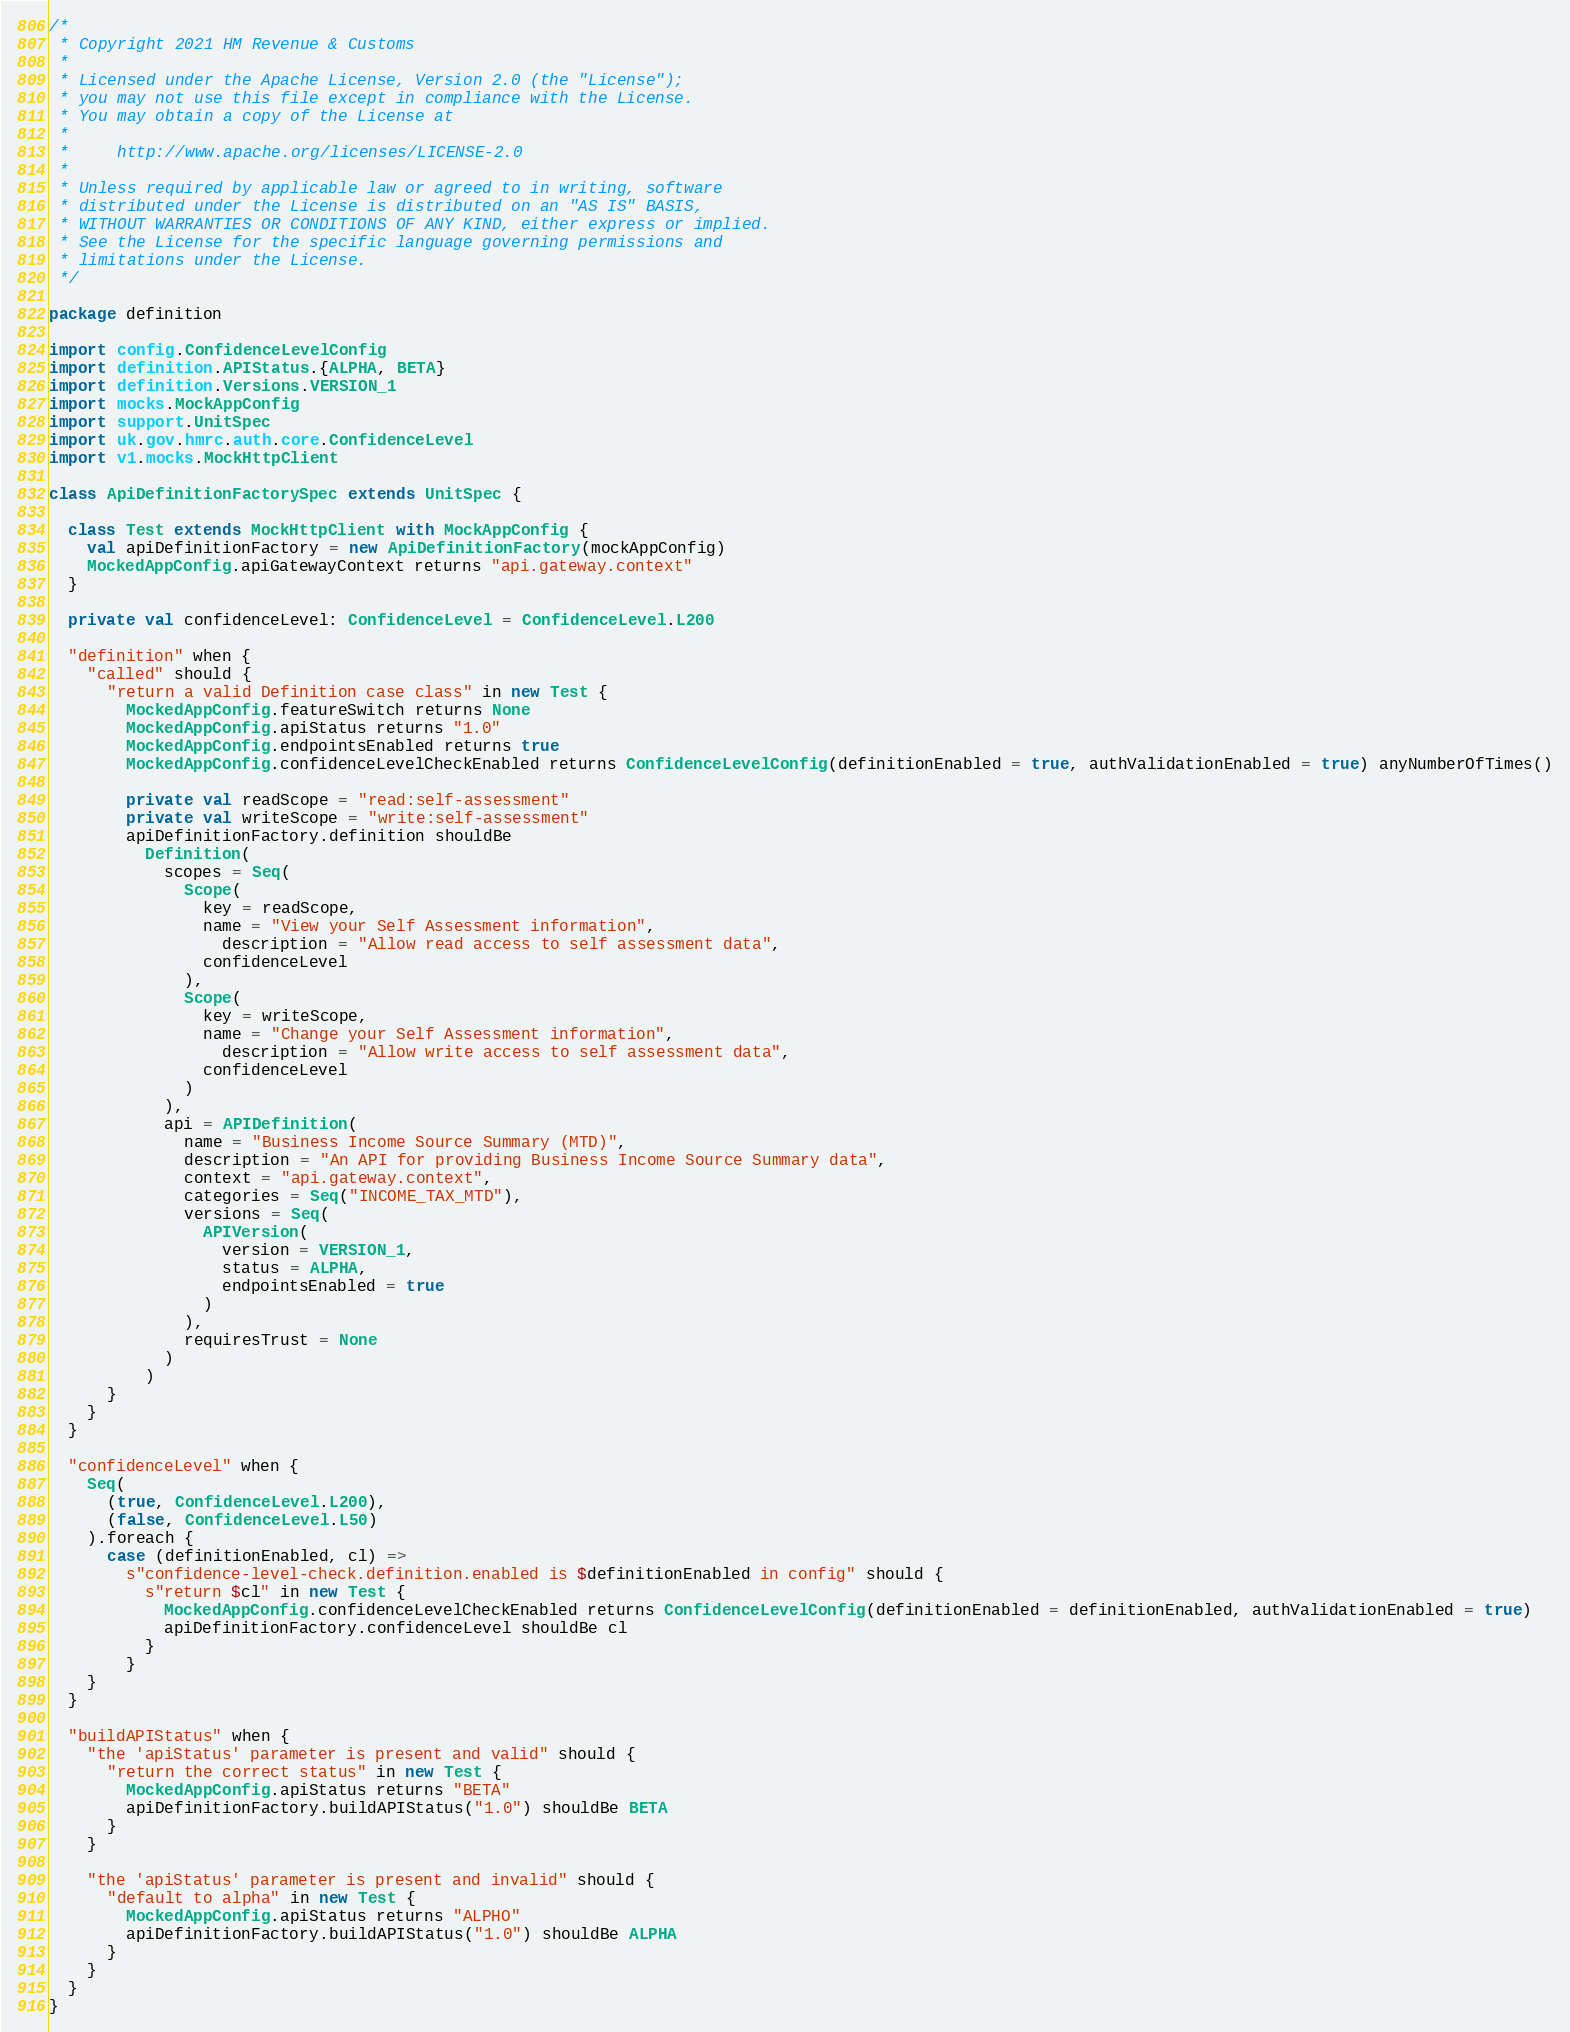Convert code to text. <code><loc_0><loc_0><loc_500><loc_500><_Scala_>/*
 * Copyright 2021 HM Revenue & Customs
 *
 * Licensed under the Apache License, Version 2.0 (the "License");
 * you may not use this file except in compliance with the License.
 * You may obtain a copy of the License at
 *
 *     http://www.apache.org/licenses/LICENSE-2.0
 *
 * Unless required by applicable law or agreed to in writing, software
 * distributed under the License is distributed on an "AS IS" BASIS,
 * WITHOUT WARRANTIES OR CONDITIONS OF ANY KIND, either express or implied.
 * See the License for the specific language governing permissions and
 * limitations under the License.
 */

package definition

import config.ConfidenceLevelConfig
import definition.APIStatus.{ALPHA, BETA}
import definition.Versions.VERSION_1
import mocks.MockAppConfig
import support.UnitSpec
import uk.gov.hmrc.auth.core.ConfidenceLevel
import v1.mocks.MockHttpClient

class ApiDefinitionFactorySpec extends UnitSpec {

  class Test extends MockHttpClient with MockAppConfig {
    val apiDefinitionFactory = new ApiDefinitionFactory(mockAppConfig)
    MockedAppConfig.apiGatewayContext returns "api.gateway.context"
  }

  private val confidenceLevel: ConfidenceLevel = ConfidenceLevel.L200

  "definition" when {
    "called" should {
      "return a valid Definition case class" in new Test {
        MockedAppConfig.featureSwitch returns None
        MockedAppConfig.apiStatus returns "1.0"
        MockedAppConfig.endpointsEnabled returns true
        MockedAppConfig.confidenceLevelCheckEnabled returns ConfidenceLevelConfig(definitionEnabled = true, authValidationEnabled = true) anyNumberOfTimes()

        private val readScope = "read:self-assessment"
        private val writeScope = "write:self-assessment"
        apiDefinitionFactory.definition shouldBe
          Definition(
            scopes = Seq(
              Scope(
                key = readScope,
                name = "View your Self Assessment information",
                  description = "Allow read access to self assessment data",
                confidenceLevel
              ),
              Scope(
                key = writeScope,
                name = "Change your Self Assessment information",
                  description = "Allow write access to self assessment data",
                confidenceLevel
              )
            ),
            api = APIDefinition(
              name = "Business Income Source Summary (MTD)",
              description = "An API for providing Business Income Source Summary data",
              context = "api.gateway.context",
              categories = Seq("INCOME_TAX_MTD"),
              versions = Seq(
                APIVersion(
                  version = VERSION_1,
                  status = ALPHA,
                  endpointsEnabled = true
                )
              ),
              requiresTrust = None
            )
          )
      }
    }
  }

  "confidenceLevel" when {
    Seq(
      (true, ConfidenceLevel.L200),
      (false, ConfidenceLevel.L50)
    ).foreach {
      case (definitionEnabled, cl) =>
        s"confidence-level-check.definition.enabled is $definitionEnabled in config" should {
          s"return $cl" in new Test {
            MockedAppConfig.confidenceLevelCheckEnabled returns ConfidenceLevelConfig(definitionEnabled = definitionEnabled, authValidationEnabled = true)
            apiDefinitionFactory.confidenceLevel shouldBe cl
          }
        }
    }
  }

  "buildAPIStatus" when {
    "the 'apiStatus' parameter is present and valid" should {
      "return the correct status" in new Test {
        MockedAppConfig.apiStatus returns "BETA"
        apiDefinitionFactory.buildAPIStatus("1.0") shouldBe BETA
      }
    }

    "the 'apiStatus' parameter is present and invalid" should {
      "default to alpha" in new Test {
        MockedAppConfig.apiStatus returns "ALPHO"
        apiDefinitionFactory.buildAPIStatus("1.0") shouldBe ALPHA
      }
    }
  }
}</code> 